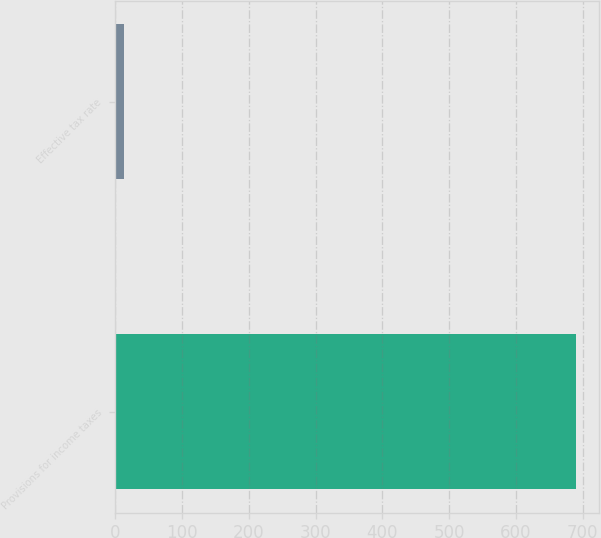Convert chart. <chart><loc_0><loc_0><loc_500><loc_500><bar_chart><fcel>Provisions for income taxes<fcel>Effective tax rate<nl><fcel>690<fcel>13<nl></chart> 